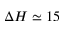Convert formula to latex. <formula><loc_0><loc_0><loc_500><loc_500>\Delta H \simeq 1 5</formula> 